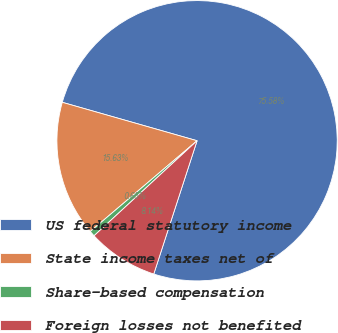Convert chart. <chart><loc_0><loc_0><loc_500><loc_500><pie_chart><fcel>US federal statutory income<fcel>State income taxes net of<fcel>Share-based compensation<fcel>Foreign losses not benefited<nl><fcel>75.58%<fcel>15.63%<fcel>0.65%<fcel>8.14%<nl></chart> 